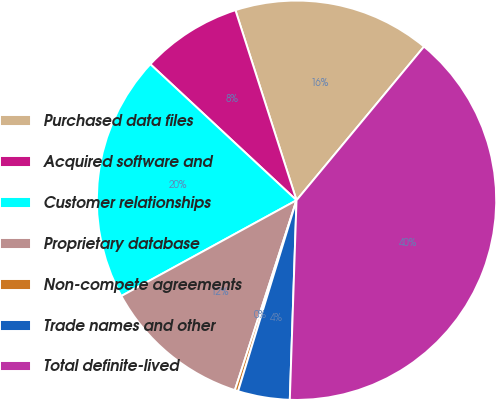Convert chart. <chart><loc_0><loc_0><loc_500><loc_500><pie_chart><fcel>Purchased data files<fcel>Acquired software and<fcel>Customer relationships<fcel>Proprietary database<fcel>Non-compete agreements<fcel>Trade names and other<fcel>Total definite-lived<nl><fcel>15.97%<fcel>8.12%<fcel>19.89%<fcel>12.04%<fcel>0.27%<fcel>4.19%<fcel>39.51%<nl></chart> 